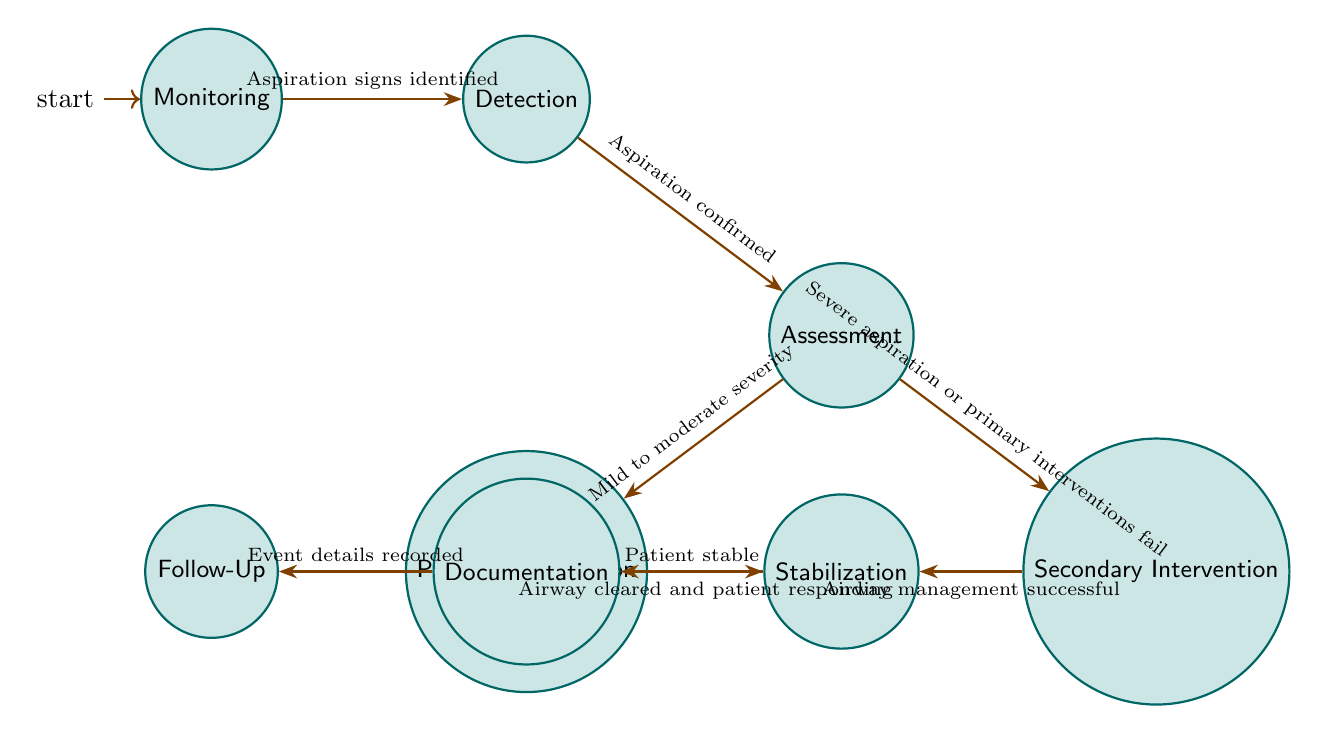What is the first state in the diagram? The diagram shows "Monitoring" as the initial state, which is indicated by its placement as the first node and the initial marker.
Answer: Monitoring How many total states are there in the diagram? By counting the distinct nodes labeled as states in the diagram, there are eight states represented.
Answer: 8 What is the condition to transition from Detection to Assessment? The arrow from Detection to Assessment is labeled with the condition "Aspiration confirmed," which dictates when this transition occurs.
Answer: Aspiration confirmed Which states lead to Stabilization? Both "Primary Intervention" and "Secondary Intervention" have direct transitions to "Stabilization," as indicated by the arrows leading from those states to Stabilization.
Answer: Primary Intervention, Secondary Intervention What must happen in the Assessment state to move to Primary Intervention? The label on the arrow from Assessment to Primary Intervention states that the condition required is "Mild to moderate severity," which means this assessment must indicate such a condition.
Answer: Mild to moderate severity What is the next state following Documentation? Following Documentation, the diagram shows an arrow leading to the next state labeled "Follow-Up," indicating this step in the emergency response sequence.
Answer: Follow-Up If a patient is in Stabilization, what condition must be met to move to Documentation? The transition from Stabilization to Documentation requires that the "Patient stable" condition is met, which is the prerequisite for this movement.
Answer: Patient stable Which state requires recording details of the event? The state labeled "Documentation" emphasizes that it is dedicated to recording event details, as indicated in the transition descriptions.
Answer: Documentation 